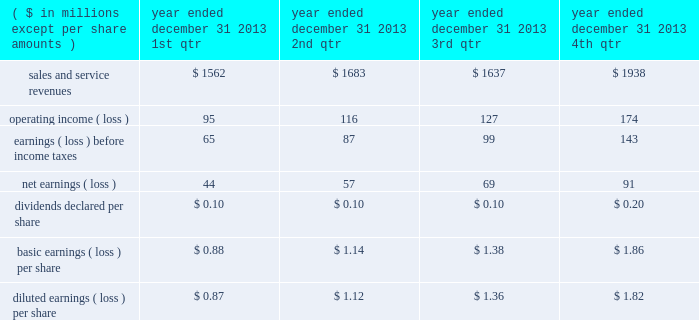"three factor formula" ) .
The consolidated financial statements include northrop grumman management and support services allocations totaling $ 32 million for the year ended december 31 , 2011 .
Shared services and infrastructure costs - this category includes costs for functions such as information technology support , systems maintenance , telecommunications , procurement and other shared services while hii was a subsidiary of northrop grumman .
These costs were generally allocated to the company using the three factor formula or based on usage .
The consolidated financial statements reflect shared services and infrastructure costs allocations totaling $ 80 million for the year ended december 31 , 2011 .
Northrop grumman-provided benefits - this category includes costs for group medical , dental and vision insurance , 401 ( k ) savings plan , pension and postretirement benefits , incentive compensation and other benefits .
These costs were generally allocated to the company based on specific identification of the benefits provided to company employees participating in these benefit plans .
The consolidated financial statements include northrop grumman- provided benefits allocations totaling $ 169 million for the year ended december 31 , 2011 .
Management believes that the methods of allocating these costs are reasonable , consistent with past practices , and in conformity with cost allocation requirements of cas or the far .
Related party sales and cost of sales prior to the spin-off , hii purchased and sold certain products and services from and to other northrop grumman entities .
Purchases of products and services from these affiliated entities , which were recorded at cost , were $ 44 million for the year ended december 31 , 2011 .
Sales of products and services to these entities were $ 1 million for the year ended december 31 , 2011 .
Former parent's equity in unit transactions between hii and northrop grumman prior to the spin-off have been included in the consolidated financial statements and were effectively settled for cash at the time the transaction was recorded .
The net effect of the settlement of these transactions is reflected as former parent's equity in unit in the consolidated statement of changes in equity .
21 .
Unaudited selected quarterly data unaudited quarterly financial results for the years ended december 31 , 2013 and 2012 , are set forth in the tables: .

For the year ended december 31 2013 , what was the net margin for the 2nd qtr? 
Computations: (116 / 1683)
Answer: 0.06892. 